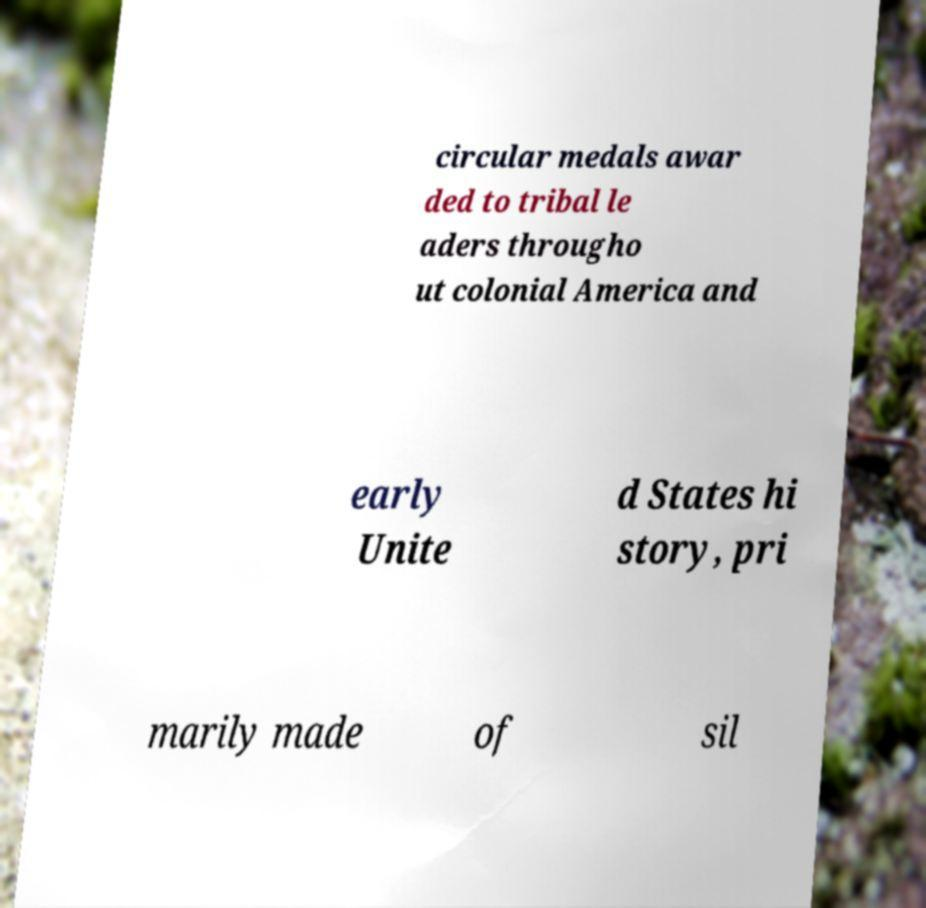Can you accurately transcribe the text from the provided image for me? circular medals awar ded to tribal le aders througho ut colonial America and early Unite d States hi story, pri marily made of sil 